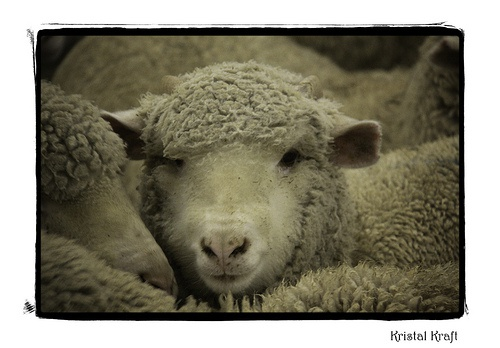Describe the objects in this image and their specific colors. I can see sheep in white, gray, darkgreen, and black tones, sheep in white, black, darkgreen, and gray tones, sheep in white, darkgreen, olive, and black tones, and sheep in white, darkgreen, black, and gray tones in this image. 